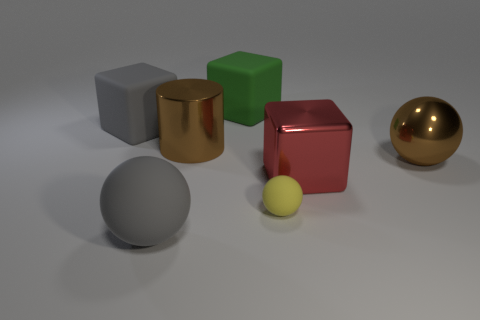Is the color of the metallic object that is left of the tiny object the same as the metallic sphere?
Offer a terse response. Yes. There is a red block; how many big matte things are behind it?
Your answer should be very brief. 2. Are there more big shiny balls than tiny red rubber things?
Offer a very short reply. Yes. The thing that is to the left of the big brown ball and to the right of the tiny yellow object has what shape?
Make the answer very short. Cube. Are any big gray matte spheres visible?
Make the answer very short. Yes. What is the material of the brown thing that is the same shape as the tiny yellow thing?
Offer a terse response. Metal. There is a red object on the right side of the ball left of the large green cube that is behind the brown ball; what shape is it?
Provide a short and direct response. Cube. There is a block that is the same color as the large matte sphere; what is its material?
Offer a very short reply. Rubber. What number of other objects have the same shape as the tiny matte thing?
Offer a very short reply. 2. There is a rubber ball that is left of the yellow rubber ball; is it the same color as the cube that is to the left of the large metal cylinder?
Give a very brief answer. Yes. 